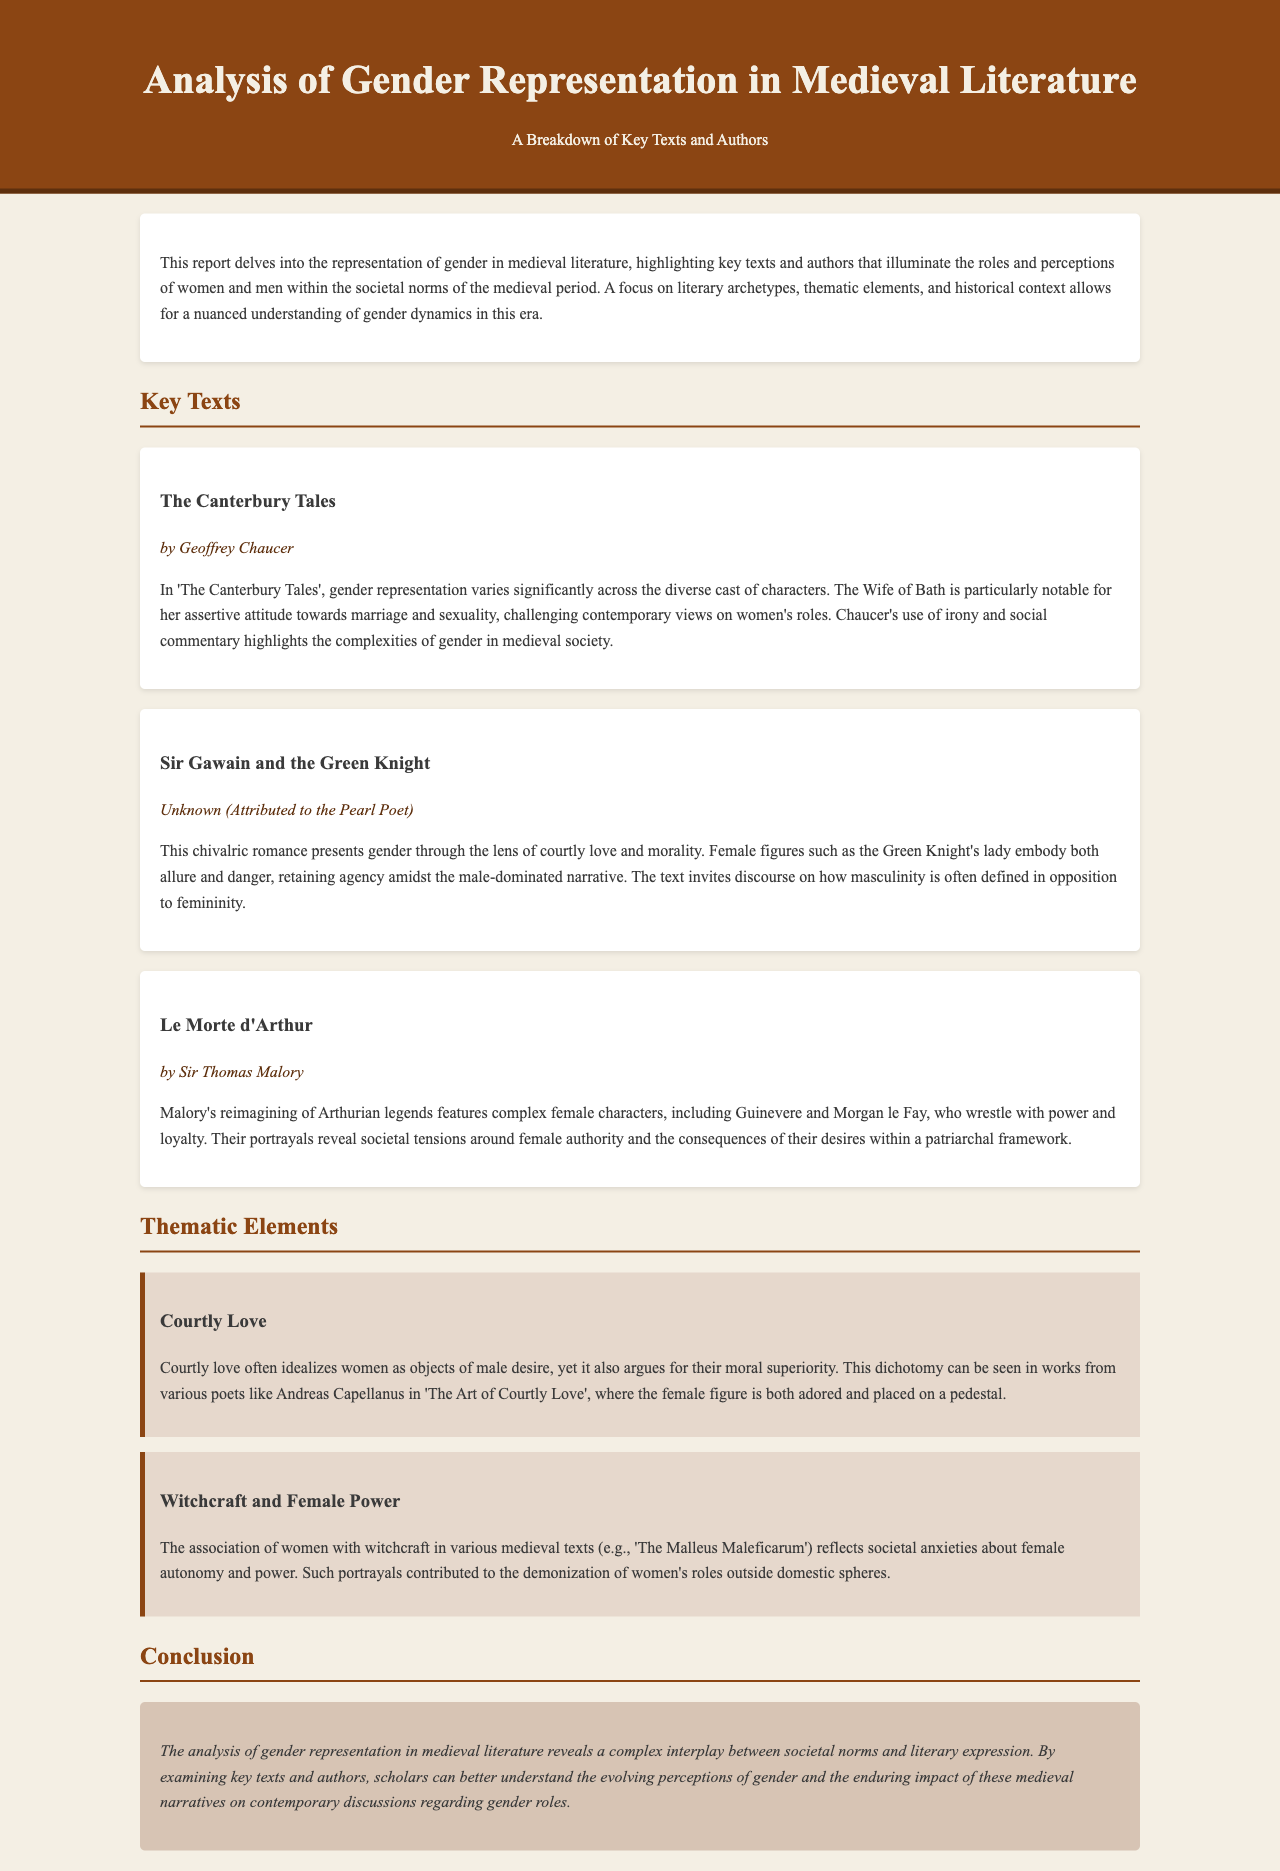What is the title of the report? The title of the report is located at the top of the document.
Answer: Analysis of Gender Representation in Medieval Literature Who is the author of 'The Canterbury Tales'? The author of 'The Canterbury Tales' is mentioned in the section discussing key texts.
Answer: Geoffrey Chaucer What theme is associated with the moral superiority of women? This theme is discussed in the thematic section of the report.
Answer: Courtly Love Which text features the character Morgan le Fay? The text where Morgan le Fay is discussed is listed in the key texts section.
Answer: Le Morte d'Arthur What societal issue does the theme of witchcraft address? The report describes the thematic focus on witchcraft and its societal implications.
Answer: Female autonomy and power How many key texts are highlighted in the report? The key texts section lists a total of three works.
Answer: Three What does the representation of the Wife of Bath challenge? The document discusses the challenges to contemporary views on women's roles by the Wife of Bath.
Answer: Marriage and sexuality What is the primary focus of the report? The focus is explicitly stated in the introductory paragraph of the report.
Answer: Gender representation in medieval literature 